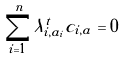<formula> <loc_0><loc_0><loc_500><loc_500>\sum _ { i = 1 } ^ { n } \lambda _ { i , a _ { i } } ^ { t } c _ { i , a } = 0</formula> 